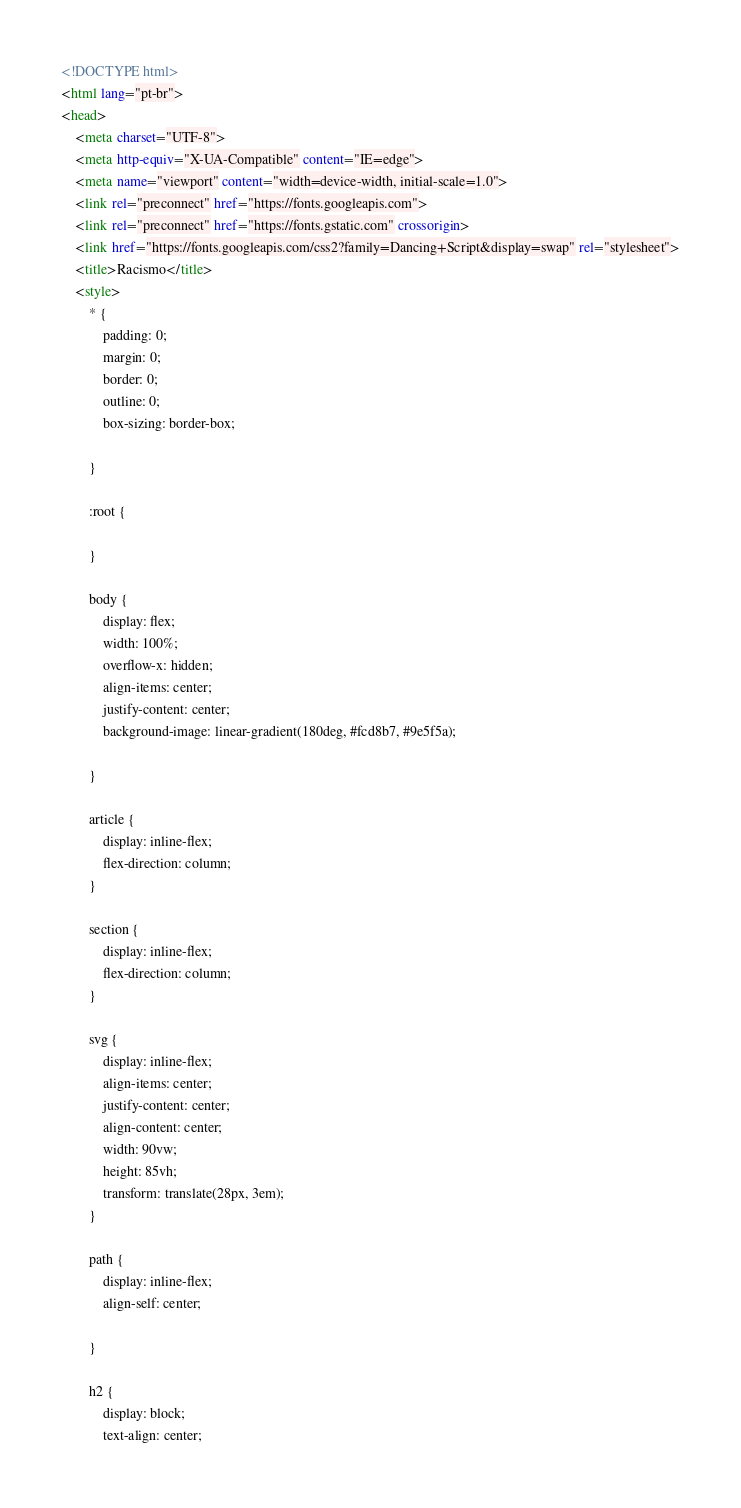Convert code to text. <code><loc_0><loc_0><loc_500><loc_500><_HTML_><!DOCTYPE html>
<html lang="pt-br">
<head>
    <meta charset="UTF-8">
    <meta http-equiv="X-UA-Compatible" content="IE=edge">
    <meta name="viewport" content="width=device-width, initial-scale=1.0">
    <link rel="preconnect" href="https://fonts.googleapis.com">
    <link rel="preconnect" href="https://fonts.gstatic.com" crossorigin>
    <link href="https://fonts.googleapis.com/css2?family=Dancing+Script&display=swap" rel="stylesheet">
    <title>Racismo</title>
    <style>
        * {
            padding: 0;
            margin: 0;
            border: 0;
            outline: 0;
            box-sizing: border-box;
            
        }

        :root {

        }

        body {
            display: flex;
            width: 100%;
            overflow-x: hidden;
            align-items: center;
            justify-content: center;
            background-image: linear-gradient(180deg, #fcd8b7, #9e5f5a);
            
        }

        article {
            display: inline-flex;
            flex-direction: column;
        }

        section {
            display: inline-flex;
            flex-direction: column;
        }

        svg {
            display: inline-flex;
            align-items: center;
            justify-content: center;
            align-content: center;
            width: 90vw;
            height: 85vh;
            transform: translate(28px, 3em);
        }

        path {
            display: inline-flex;
            align-self: center;
            
        }

        h2 {
            display: block;
            text-align: center;</code> 